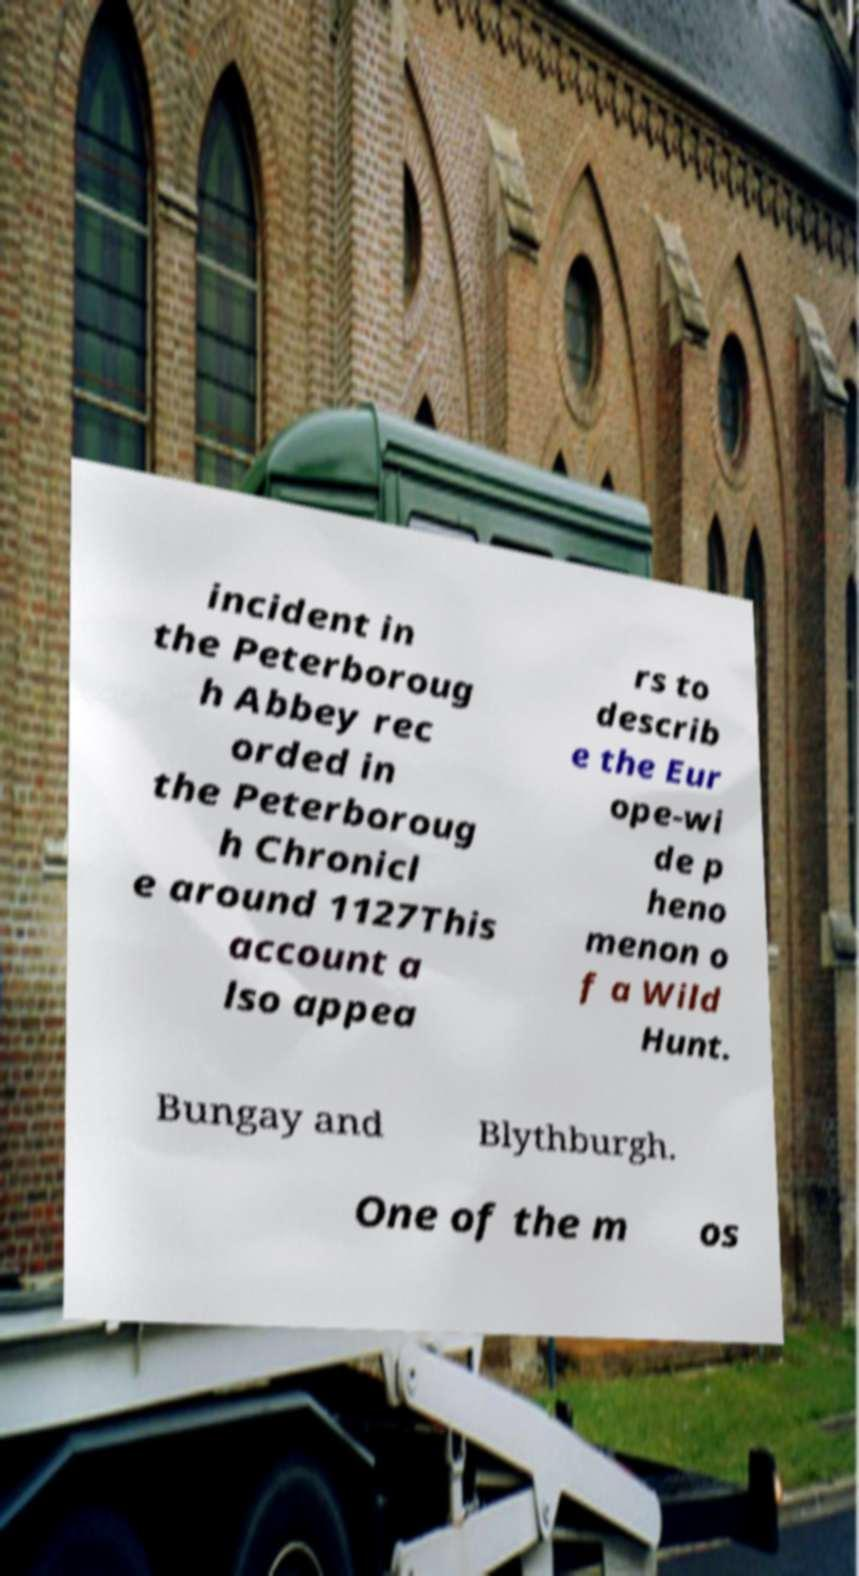Could you extract and type out the text from this image? incident in the Peterboroug h Abbey rec orded in the Peterboroug h Chronicl e around 1127This account a lso appea rs to describ e the Eur ope-wi de p heno menon o f a Wild Hunt. Bungay and Blythburgh. One of the m os 